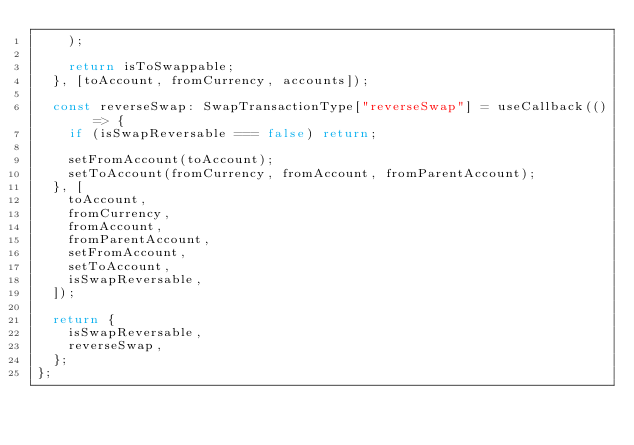Convert code to text. <code><loc_0><loc_0><loc_500><loc_500><_TypeScript_>    );

    return isToSwappable;
  }, [toAccount, fromCurrency, accounts]);

  const reverseSwap: SwapTransactionType["reverseSwap"] = useCallback(() => {
    if (isSwapReversable === false) return;

    setFromAccount(toAccount);
    setToAccount(fromCurrency, fromAccount, fromParentAccount);
  }, [
    toAccount,
    fromCurrency,
    fromAccount,
    fromParentAccount,
    setFromAccount,
    setToAccount,
    isSwapReversable,
  ]);

  return {
    isSwapReversable,
    reverseSwap,
  };
};
</code> 